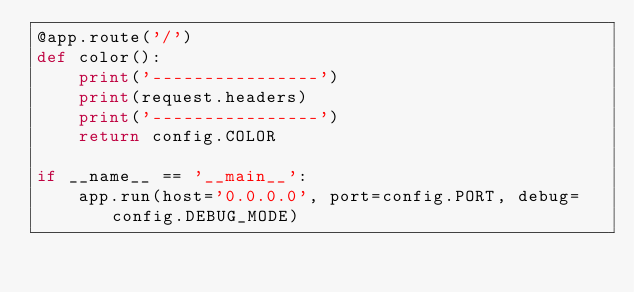<code> <loc_0><loc_0><loc_500><loc_500><_Python_>@app.route('/')
def color():
    print('----------------')
    print(request.headers)
    print('----------------')
    return config.COLOR

if __name__ == '__main__':
    app.run(host='0.0.0.0', port=config.PORT, debug=config.DEBUG_MODE)</code> 